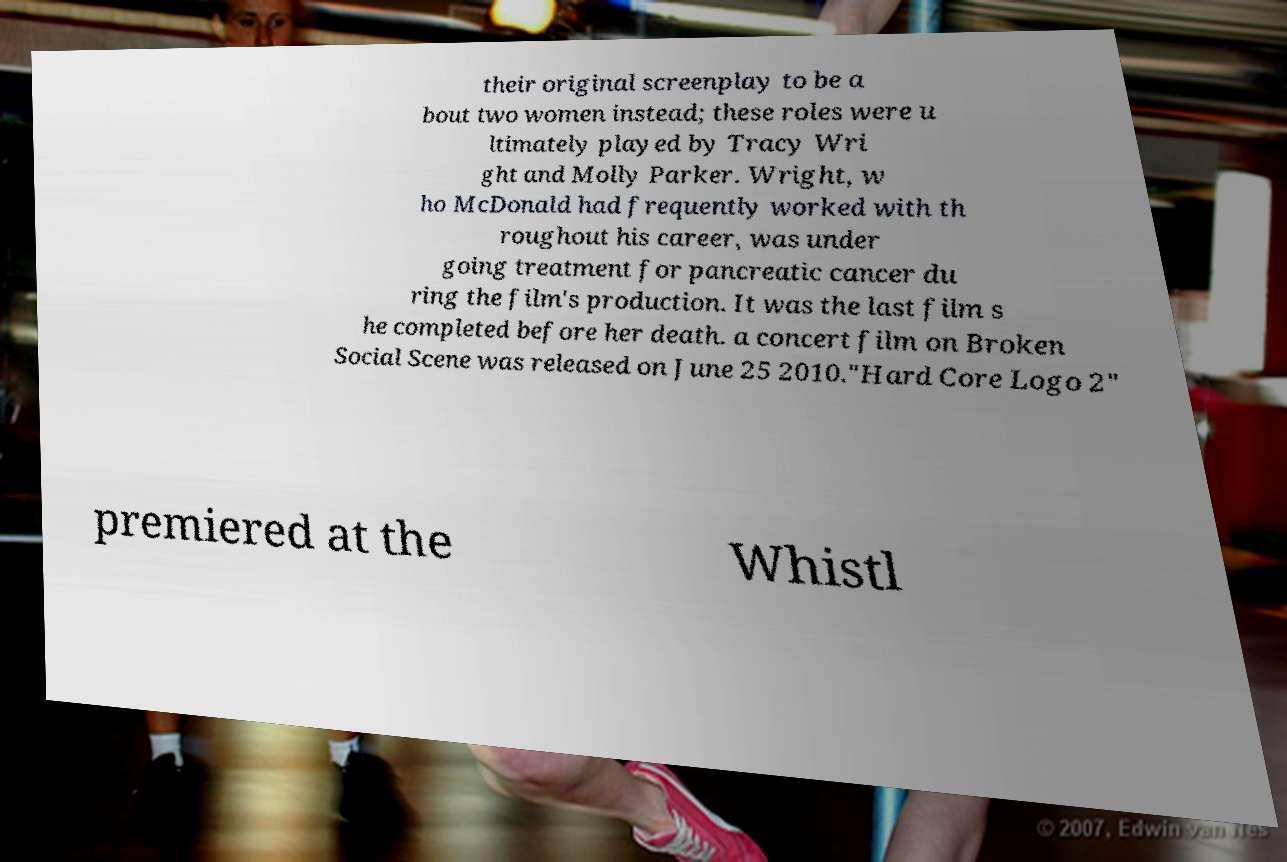Please identify and transcribe the text found in this image. their original screenplay to be a bout two women instead; these roles were u ltimately played by Tracy Wri ght and Molly Parker. Wright, w ho McDonald had frequently worked with th roughout his career, was under going treatment for pancreatic cancer du ring the film's production. It was the last film s he completed before her death. a concert film on Broken Social Scene was released on June 25 2010."Hard Core Logo 2" premiered at the Whistl 